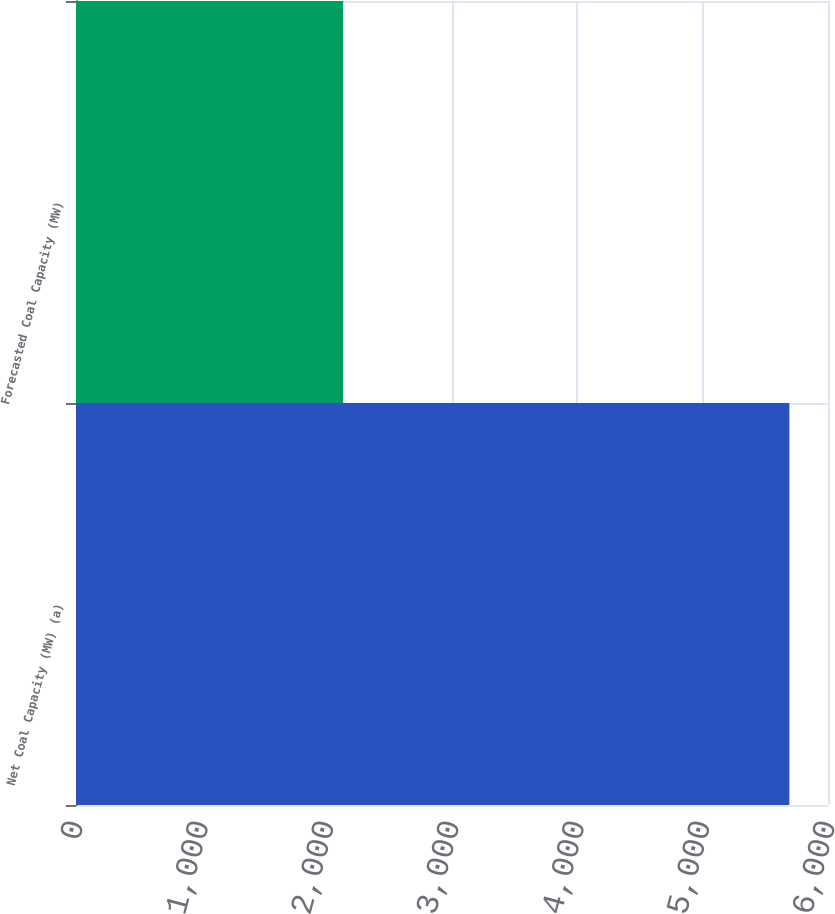Convert chart to OTSL. <chart><loc_0><loc_0><loc_500><loc_500><bar_chart><fcel>Net Coal Capacity (MW) (a)<fcel>Forecasted Coal Capacity (MW)<nl><fcel>5692<fcel>2132<nl></chart> 